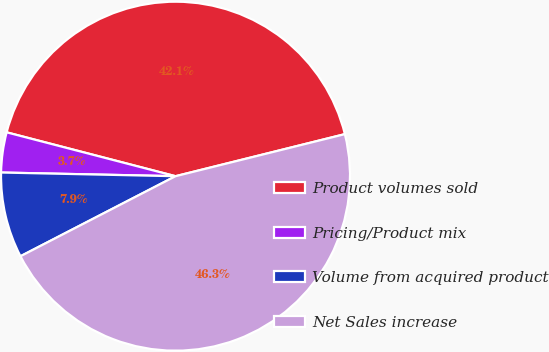Convert chart to OTSL. <chart><loc_0><loc_0><loc_500><loc_500><pie_chart><fcel>Product volumes sold<fcel>Pricing/Product mix<fcel>Volume from acquired product<fcel>Net Sales increase<nl><fcel>42.08%<fcel>3.71%<fcel>7.92%<fcel>46.29%<nl></chart> 